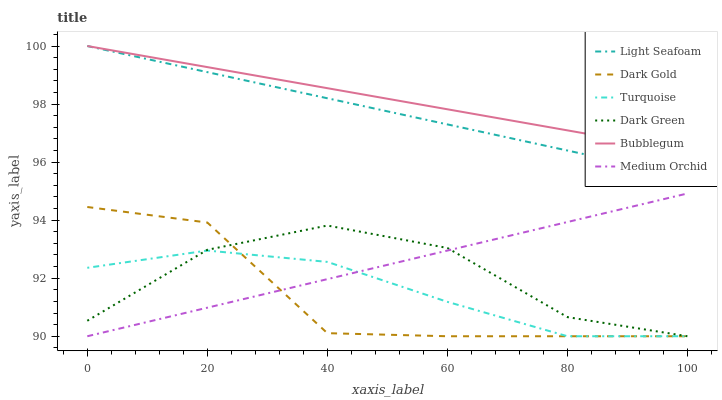Does Dark Gold have the minimum area under the curve?
Answer yes or no. Yes. Does Bubblegum have the maximum area under the curve?
Answer yes or no. Yes. Does Medium Orchid have the minimum area under the curve?
Answer yes or no. No. Does Medium Orchid have the maximum area under the curve?
Answer yes or no. No. Is Medium Orchid the smoothest?
Answer yes or no. Yes. Is Dark Gold the roughest?
Answer yes or no. Yes. Is Dark Gold the smoothest?
Answer yes or no. No. Is Medium Orchid the roughest?
Answer yes or no. No. Does Turquoise have the lowest value?
Answer yes or no. Yes. Does Bubblegum have the lowest value?
Answer yes or no. No. Does Light Seafoam have the highest value?
Answer yes or no. Yes. Does Dark Gold have the highest value?
Answer yes or no. No. Is Dark Gold less than Bubblegum?
Answer yes or no. Yes. Is Light Seafoam greater than Dark Gold?
Answer yes or no. Yes. Does Medium Orchid intersect Turquoise?
Answer yes or no. Yes. Is Medium Orchid less than Turquoise?
Answer yes or no. No. Is Medium Orchid greater than Turquoise?
Answer yes or no. No. Does Dark Gold intersect Bubblegum?
Answer yes or no. No. 